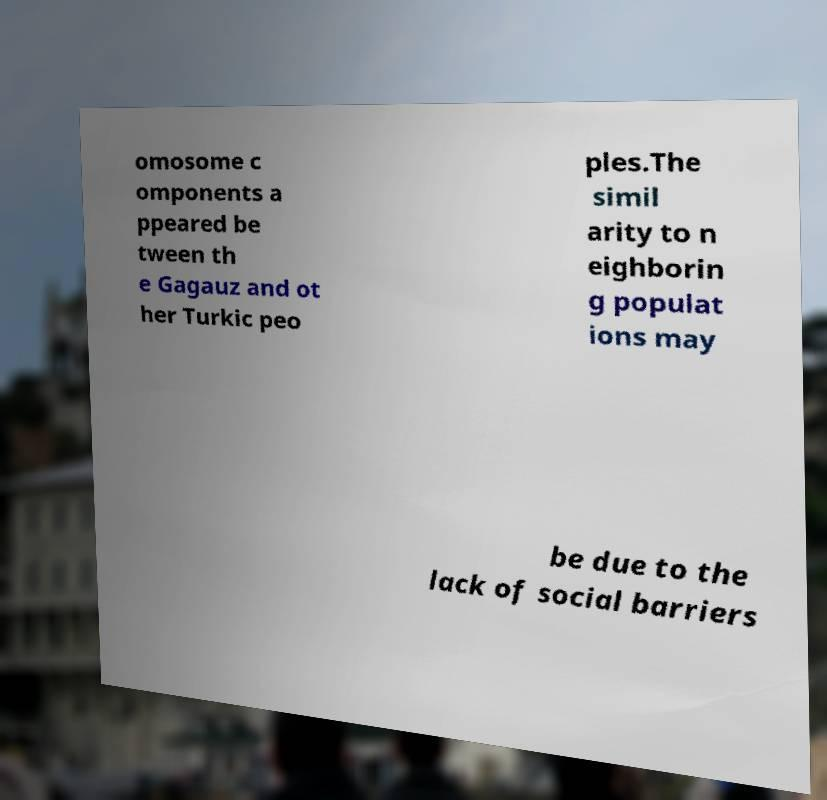Could you assist in decoding the text presented in this image and type it out clearly? omosome c omponents a ppeared be tween th e Gagauz and ot her Turkic peo ples.The simil arity to n eighborin g populat ions may be due to the lack of social barriers 